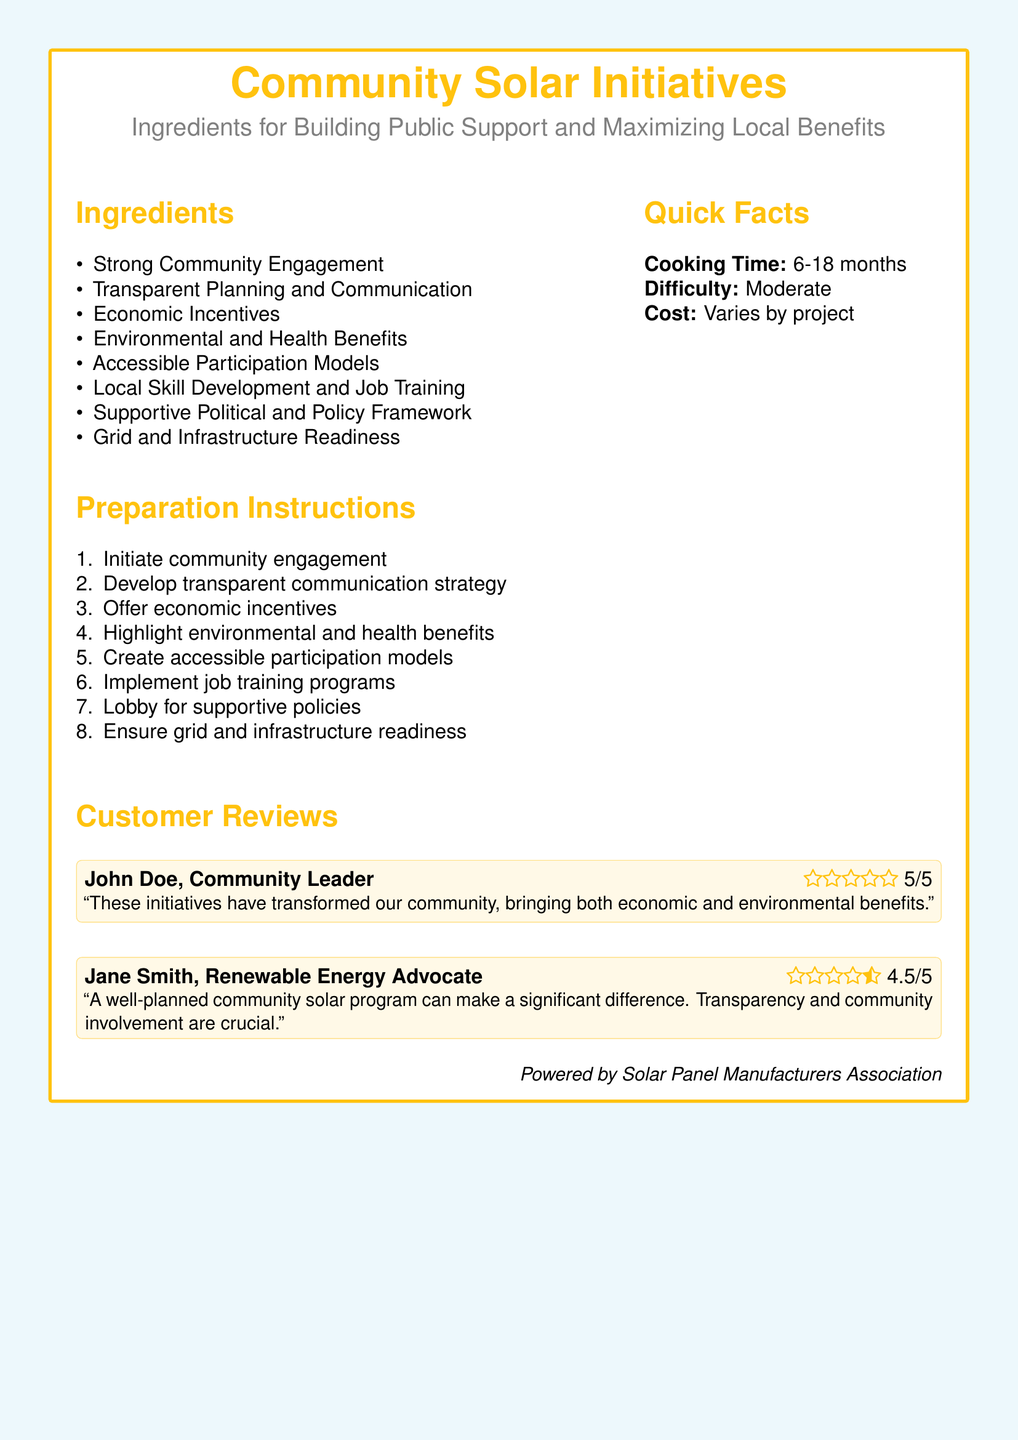what is the cooking time for community solar initiatives? The cooking time is specified in the document as a range from 6 to 18 months.
Answer: 6-18 months who is a community leader that provided a review? The document mentions John Doe as a community leader who provided a review.
Answer: John Doe what is one of the economic benefits of community solar initiatives? The document lists "Economic Incentives" as one of the ingredients for building public support.
Answer: Economic Incentives what is the difficulty level of the community solar initiatives? The difficulty level is categorized as moderate in the document.
Answer: Moderate how many ingredients are listed for building public support? The document contains a list of ingredients, and the total count is included in that list.
Answer: Eight what is one of the key components of preparation instructions? The preparation instructions include several steps, one of which is to "Initiate community engagement."
Answer: Initiate community engagement who is a renewable energy advocate that rated the initiative? The document names Jane Smith as a renewable energy advocate who provided a rating.
Answer: Jane Smith what type of box is used to highlight customer reviews? The document describes the use of a tcolorbox for customer reviews.
Answer: tcolorbox what should be highlighted to build public support according to the document? "Environmental and health benefits" is mentioned as an important aspect to highlight in the document.
Answer: Environmental and health benefits 